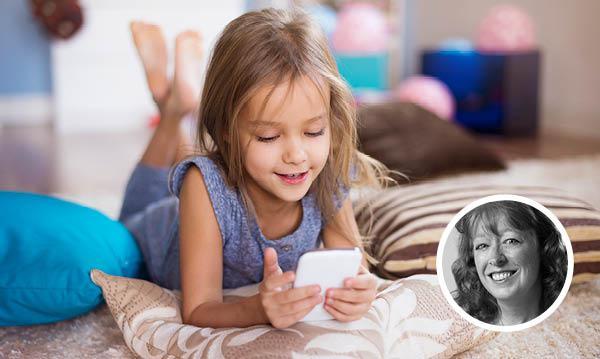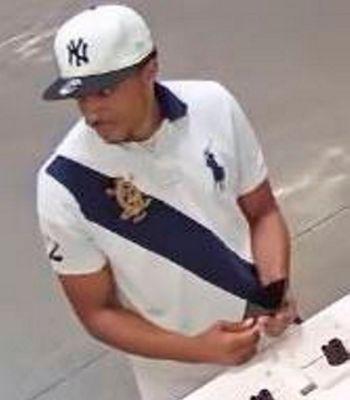The first image is the image on the left, the second image is the image on the right. For the images shown, is this caption "In the image to the left, a person is holding a phone; the phone is not up to anyone's ear." true? Answer yes or no. Yes. The first image is the image on the left, the second image is the image on the right. Considering the images on both sides, is "Only one person is holding a phone to their ear." valid? Answer yes or no. No. 